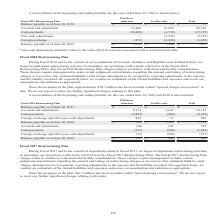According to Opentext Corporation's financial document, What does the table show? reconciliation of the beginning and ending liability for the year ended June 30, 2019 and 2018. The document states: "A reconciliation of the beginning and ending liability for the year ended June 30, 2019 and 2018 is shown below...." Also, How much has been  recorded within "Special charges (recoveries)" since the inception of the plan to date? According to the financial document, $10.7 million. The relevant text states: "Since the inception of the plan, approximately $10.7 million has been recorded within "Special charges (recoveries)" to date. We do not expect to incur any furth..." Also, What is the Balance payable as at June 30, 2019 for workforce reduction? According to the financial document, 150 (in thousands). The relevant text states: "(286) (337) Balance payable as at June 30, 2019 $ 150 $ 486 $ 636..." Also, can you calculate: What is the Balance payable as at June 30, 2019 for Workforce reduction expressed as a percentage of total Balance payable as at June 30, 2019?  Based on the calculation: 150/636, the result is 23.58 (percentage). This is based on the information: "(286) (337) Balance payable as at June 30, 2019 $ 150 $ 486 $ 636 Balance payable as at June 30, 2019 $ 150 $ 486 $ 636..." The key data points involved are: 150, 636. Also, can you calculate: What is the difference between the total Balance payable as at June 30, 2019 vs that of 2018? Based on the calculation: 636-1,723, the result is -1087 (in thousands). This is based on the information: "lance payable as at June 30, 2018 $ 558 $ 1,165 $ 1,723 Accruals and adjustments (20) 535 515 Cash payments (337) (928) (1,265) Foreign exchange and other Balance payable as at June 30, 2019 $ 150 $ 4..." The key data points involved are: 1,723, 636. Also, can you calculate: For Balance payable as at June 30, 2019, What is the difference between Workforce reduction and Facility costs? Based on the calculation: 150-486, the result is -336 (in thousands). This is based on the information: "(286) (337) Balance payable as at June 30, 2019 $ 150 $ 486 $ 636 (337) Balance payable as at June 30, 2019 $ 150 $ 486 $ 636..." The key data points involved are: 150, 486. 